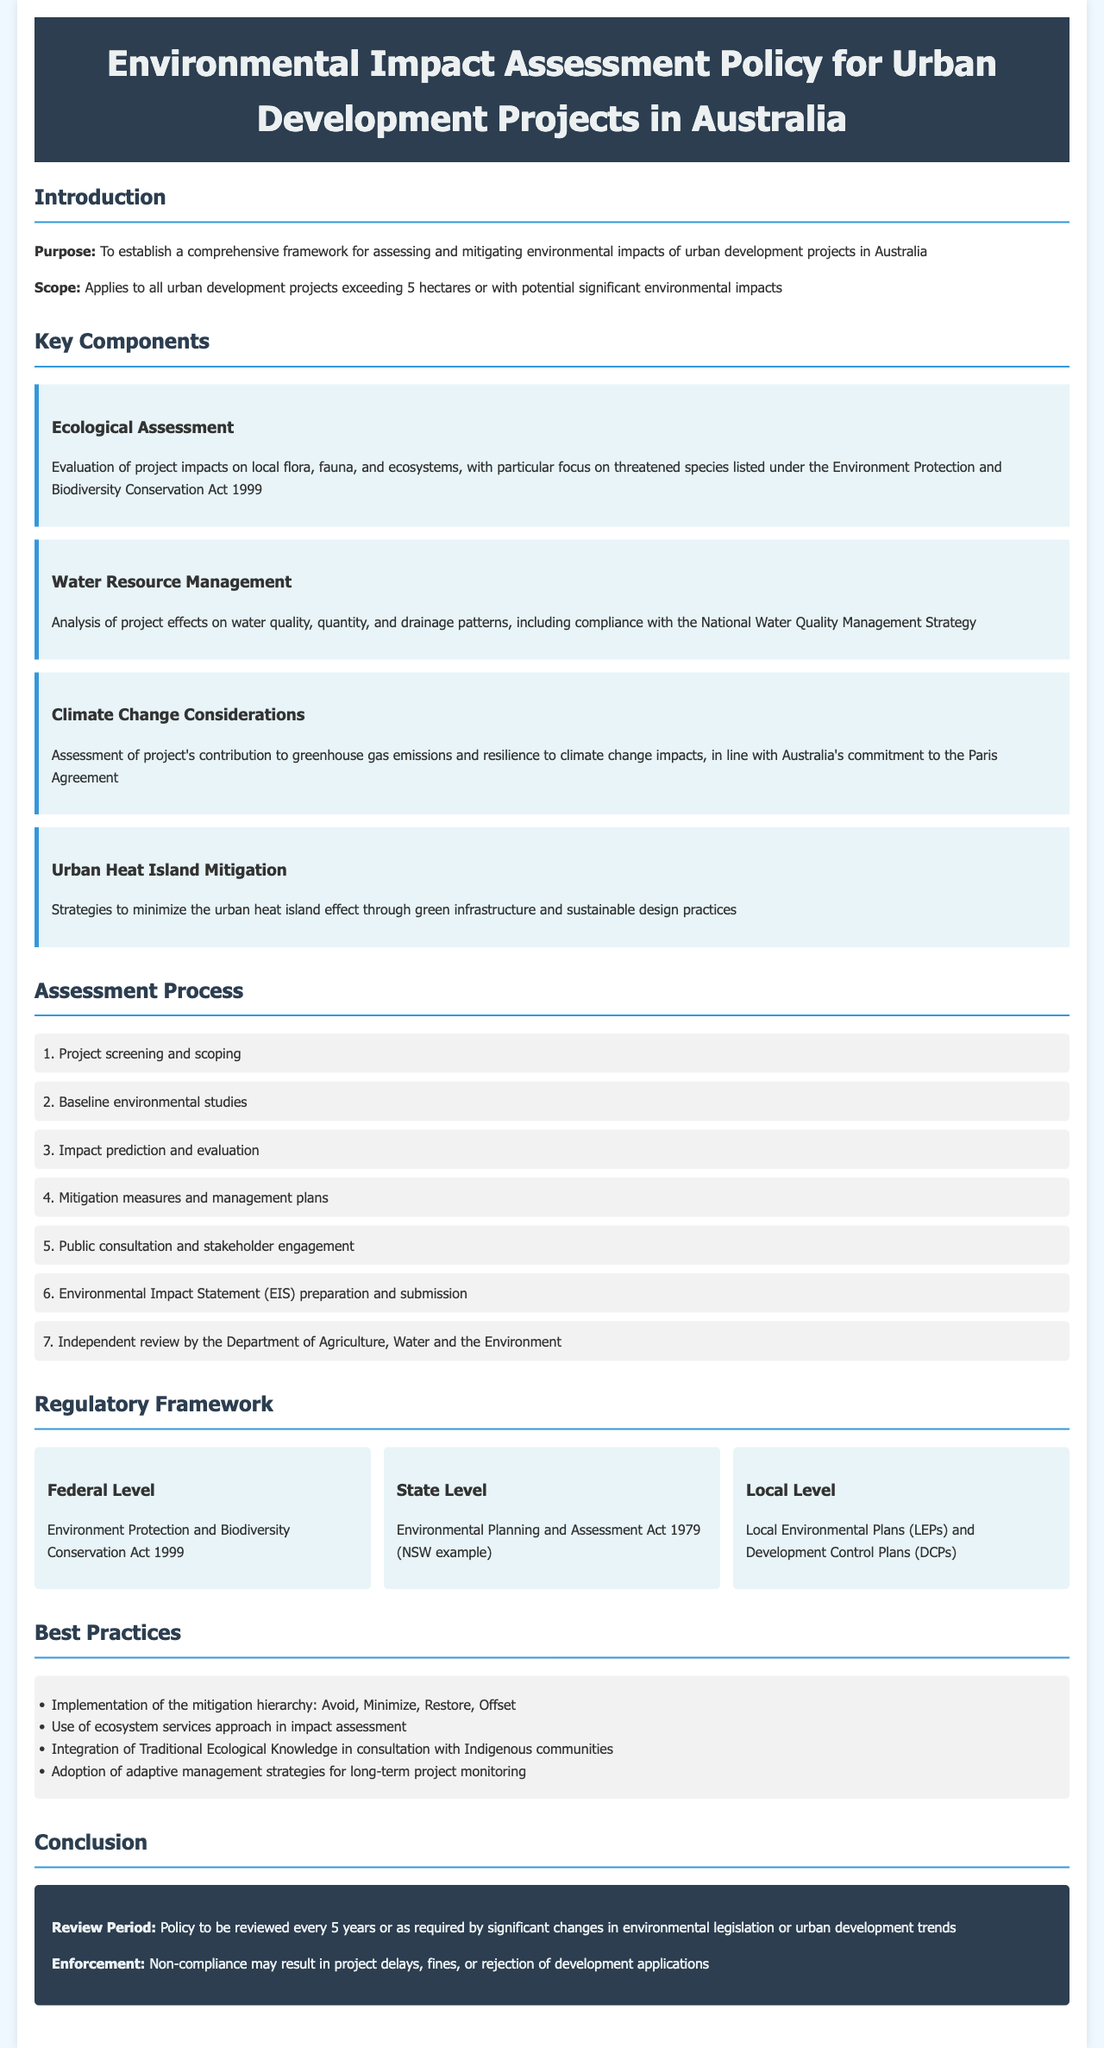What is the purpose of the policy? The purpose of the policy is to establish a comprehensive framework for assessing and mitigating environmental impacts of urban development projects in Australia.
Answer: To establish a comprehensive framework for assessing and mitigating environmental impacts of urban development projects in Australia What is the scope of the policy? The scope of the policy applies to all urban development projects exceeding 5 hectares or with potential significant environmental impacts.
Answer: Applies to all urban development projects exceeding 5 hectares or with potential significant environmental impacts How many key components are listed in the document? The document lists four key components related to environmental assessment for urban development projects.
Answer: Four What is one of the strategies for urban heat island mitigation? The document mentions strategies to minimize the urban heat island effect through green infrastructure and sustainable design practices.
Answer: Green infrastructure and sustainable design practices Which act is mentioned at the federal level in the regulatory framework? The act mentioned at the federal level is the Environment Protection and Biodiversity Conservation Act 1999.
Answer: Environment Protection and Biodiversity Conservation Act 1999 What is the review period for the policy? The policy is to be reviewed every 5 years or as required by significant changes in environmental legislation or urban development trends.
Answer: Every 5 years What does non-compliance with the policy potentially result in? Non-compliance may result in project delays, fines, or rejection of development applications.
Answer: Project delays, fines, or rejection of development applications What assessment is required for local flora, fauna, and ecosystems? An ecological assessment is required, focusing on impacts on local flora, fauna, and ecosystems.
Answer: Ecological assessment How many steps are in the assessment process? There are seven steps outlined in the assessment process for urban development projects.
Answer: Seven 